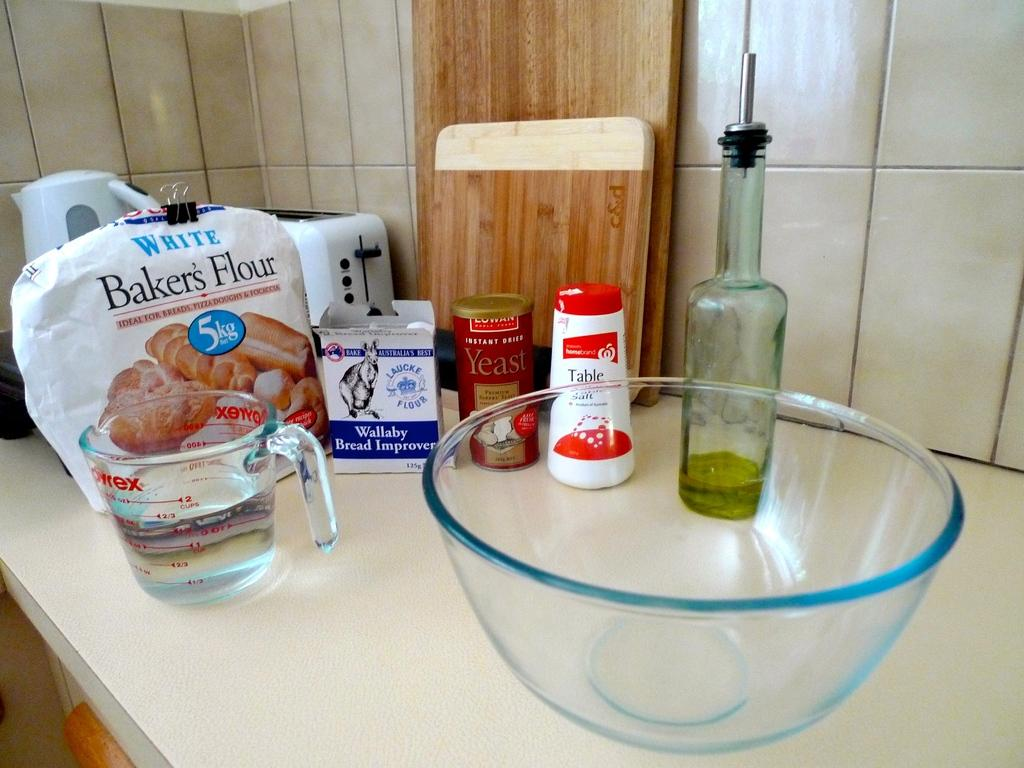<image>
Share a concise interpretation of the image provided. A counter with a glass bowl and Pyrex measuring cup with baking ingredients including a bag of White Baker's Flour. 